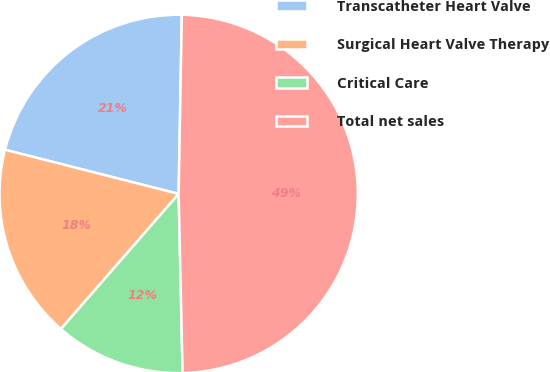Convert chart. <chart><loc_0><loc_0><loc_500><loc_500><pie_chart><fcel>Transcatheter Heart Valve<fcel>Surgical Heart Valve Therapy<fcel>Critical Care<fcel>Total net sales<nl><fcel>21.32%<fcel>17.56%<fcel>11.76%<fcel>49.37%<nl></chart> 